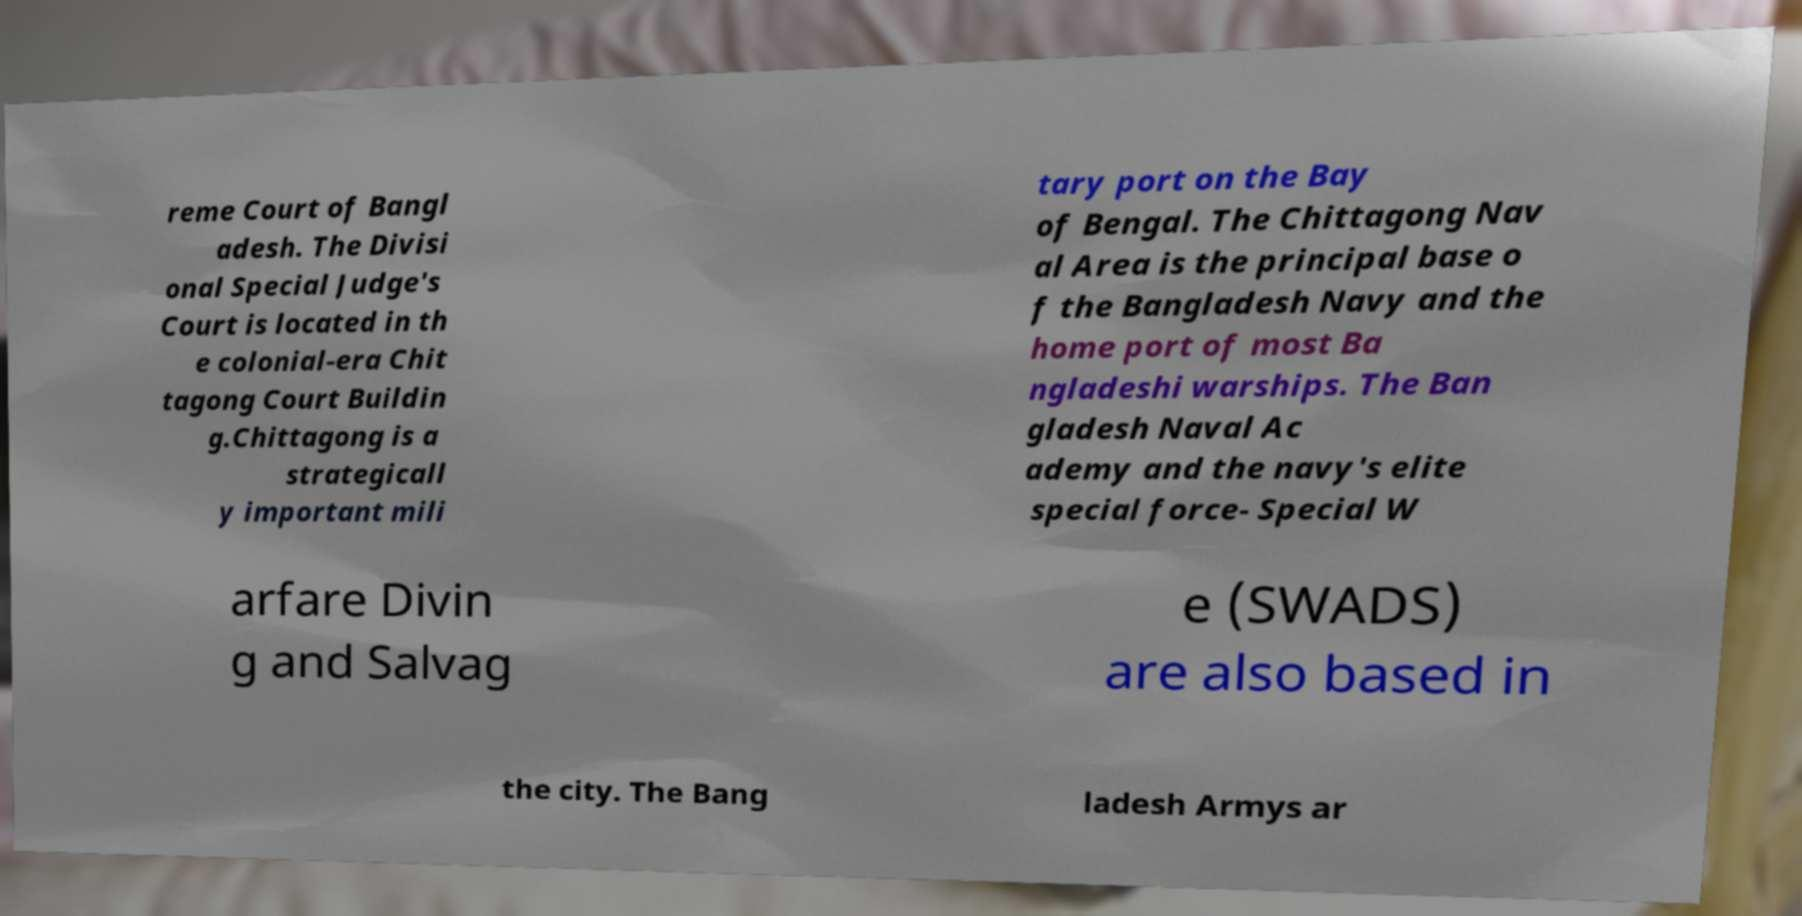Please read and relay the text visible in this image. What does it say? reme Court of Bangl adesh. The Divisi onal Special Judge's Court is located in th e colonial-era Chit tagong Court Buildin g.Chittagong is a strategicall y important mili tary port on the Bay of Bengal. The Chittagong Nav al Area is the principal base o f the Bangladesh Navy and the home port of most Ba ngladeshi warships. The Ban gladesh Naval Ac ademy and the navy's elite special force- Special W arfare Divin g and Salvag e (SWADS) are also based in the city. The Bang ladesh Armys ar 